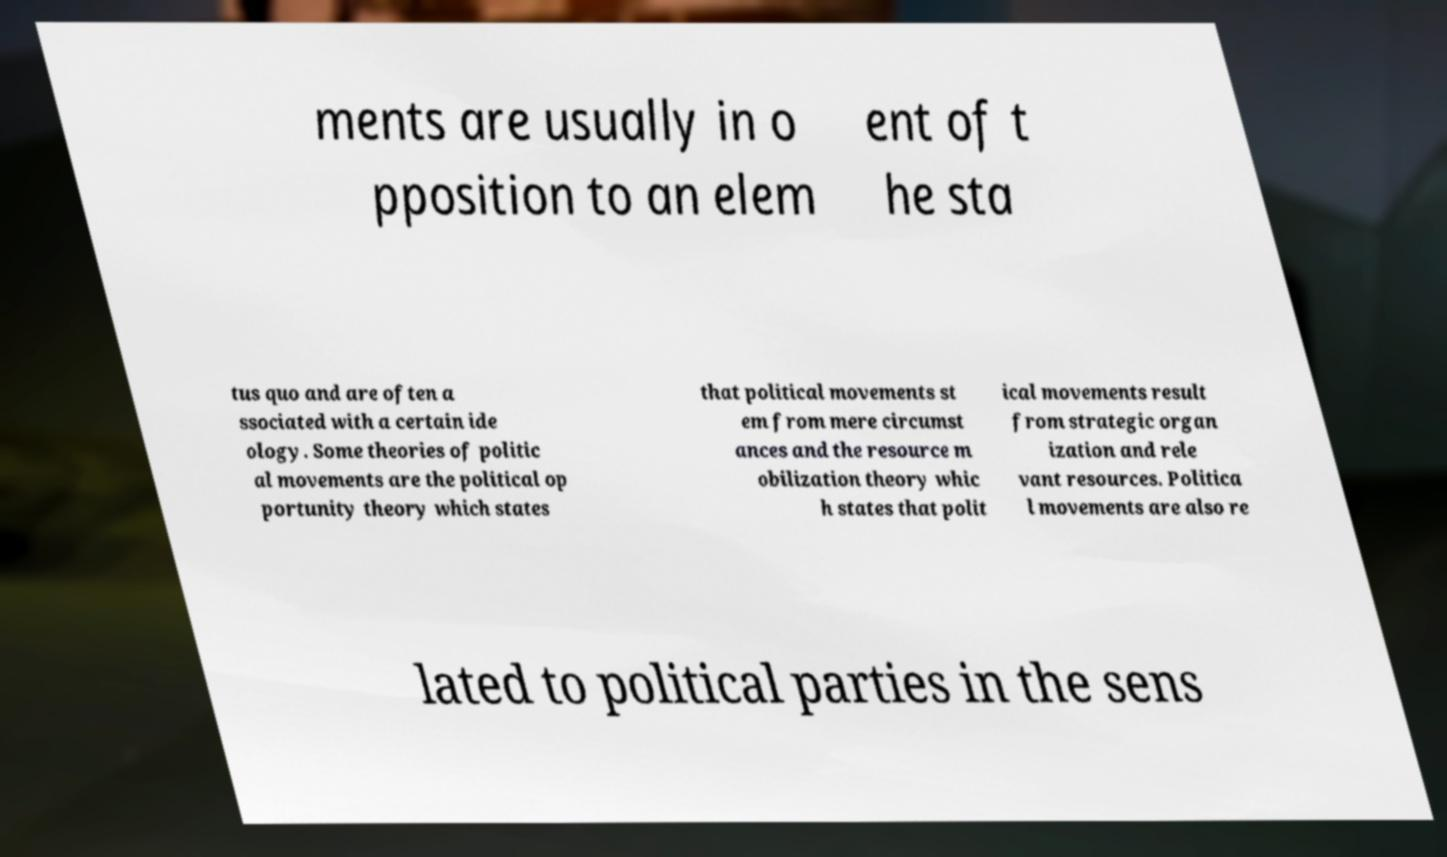Can you accurately transcribe the text from the provided image for me? ments are usually in o pposition to an elem ent of t he sta tus quo and are often a ssociated with a certain ide ology. Some theories of politic al movements are the political op portunity theory which states that political movements st em from mere circumst ances and the resource m obilization theory whic h states that polit ical movements result from strategic organ ization and rele vant resources. Politica l movements are also re lated to political parties in the sens 